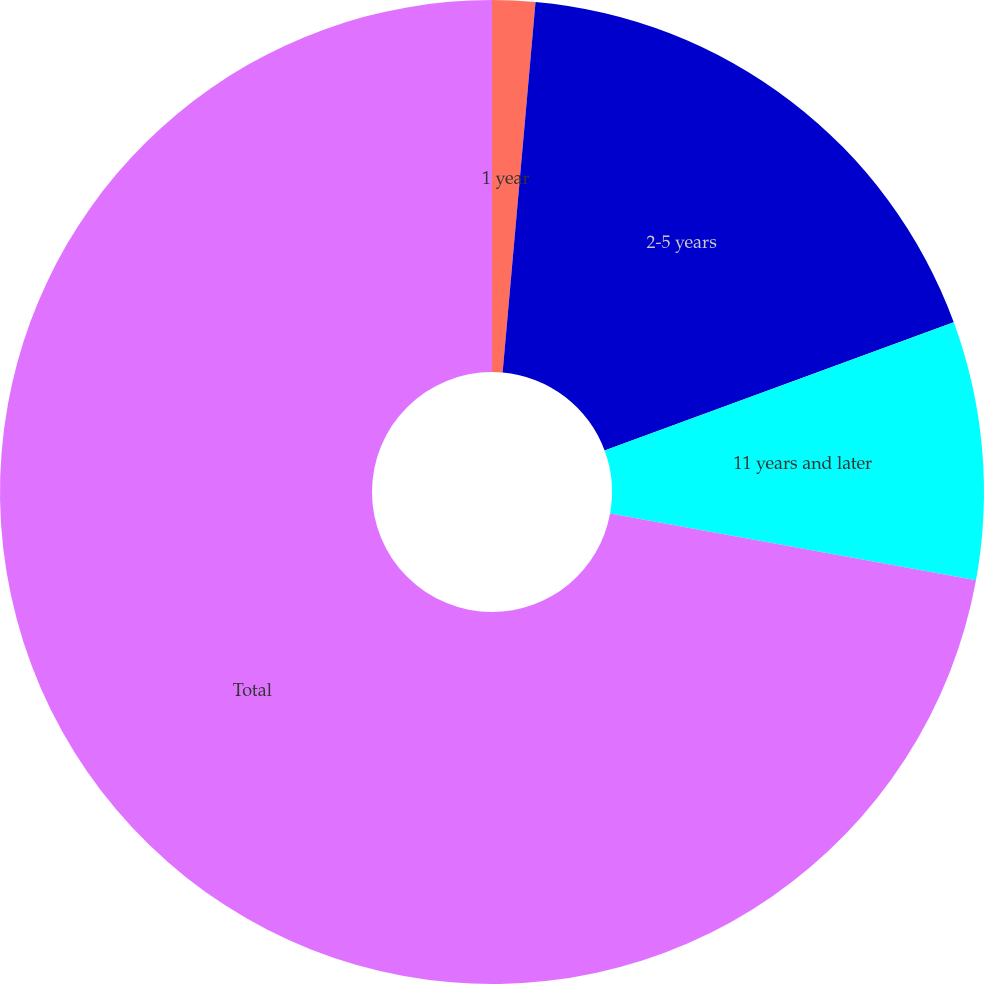Convert chart to OTSL. <chart><loc_0><loc_0><loc_500><loc_500><pie_chart><fcel>1 year<fcel>2-5 years<fcel>11 years and later<fcel>Total<nl><fcel>1.41%<fcel>17.98%<fcel>8.48%<fcel>72.12%<nl></chart> 